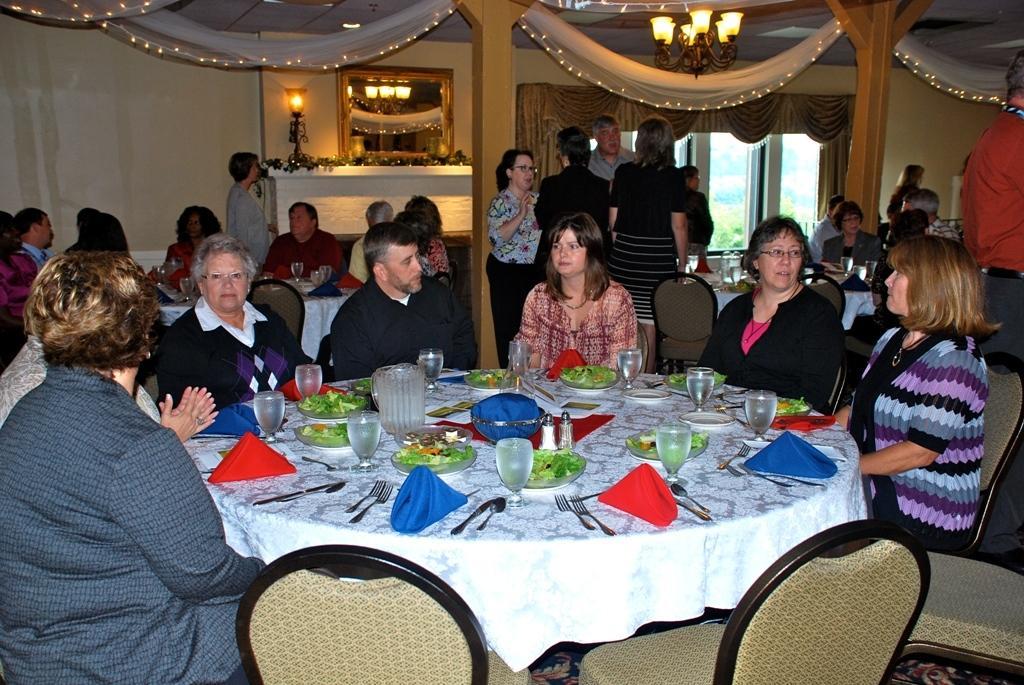Please provide a concise description of this image. In this image, we can see a group of people. Few people are sitting on the chairs. Here we can see tables covered with clothes. So many things and objects are placed on it. At the bottom, we can see chairs and floor. Background we can see people are standing. Here we can see wall, light, mirror, pillars, curtains, glass window, chandelier and decorative objects. 